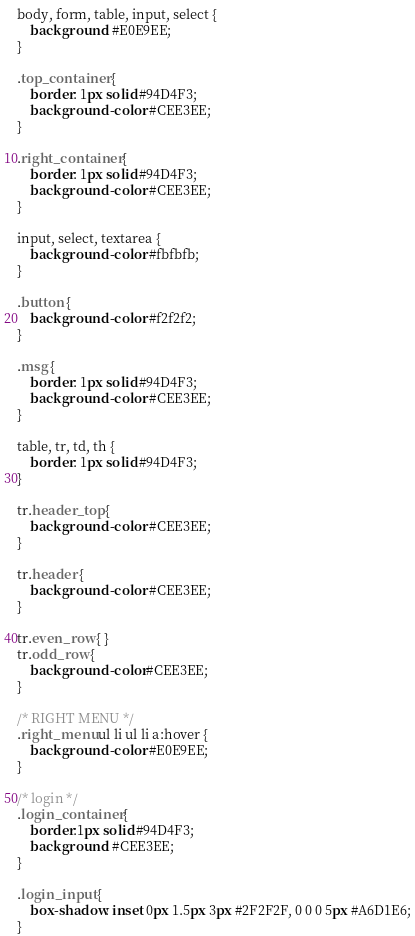<code> <loc_0><loc_0><loc_500><loc_500><_CSS_>body, form, table, input, select {
    background: #E0E9EE;
}

.top_container {
    border: 1px solid #94D4F3;
    background-color: #CEE3EE;
}

.right_container {
    border: 1px solid #94D4F3;
    background-color: #CEE3EE;
}

input, select, textarea {
    background-color: #fbfbfb;
}

.button {
    background-color: #f2f2f2;
}

.msg {
    border: 1px solid #94D4F3;
    background-color: #CEE3EE;
}

table, tr, td, th {
    border: 1px solid #94D4F3;
}

tr.header_top {
    background-color: #CEE3EE;
}

tr.header {
    background-color: #CEE3EE;
}

tr.even_row { }
tr.odd_row {
    background-color:#CEE3EE;
}

/* RIGHT MENU */
.right_menu ul li ul li a:hover {
    background-color: #E0E9EE;
}

/* login */
.login_container {
    border:1px solid #94D4F3;
    background: #CEE3EE;
}

.login_input {
    box-shadow: inset 0px 1.5px 3px #2F2F2F, 0 0 0 5px #A6D1E6;
}
</code> 